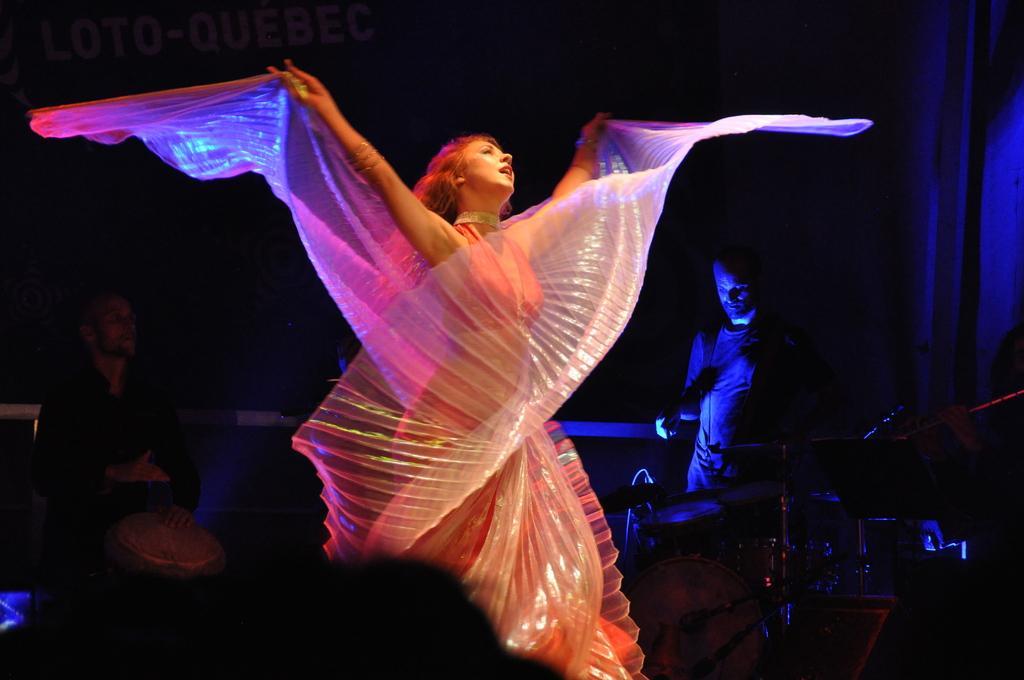Please provide a concise description of this image. In this picture I can see a woman standing. I can see two persons, drums, cymbals with the cymbals stands and some other objects, and there is dark background. 